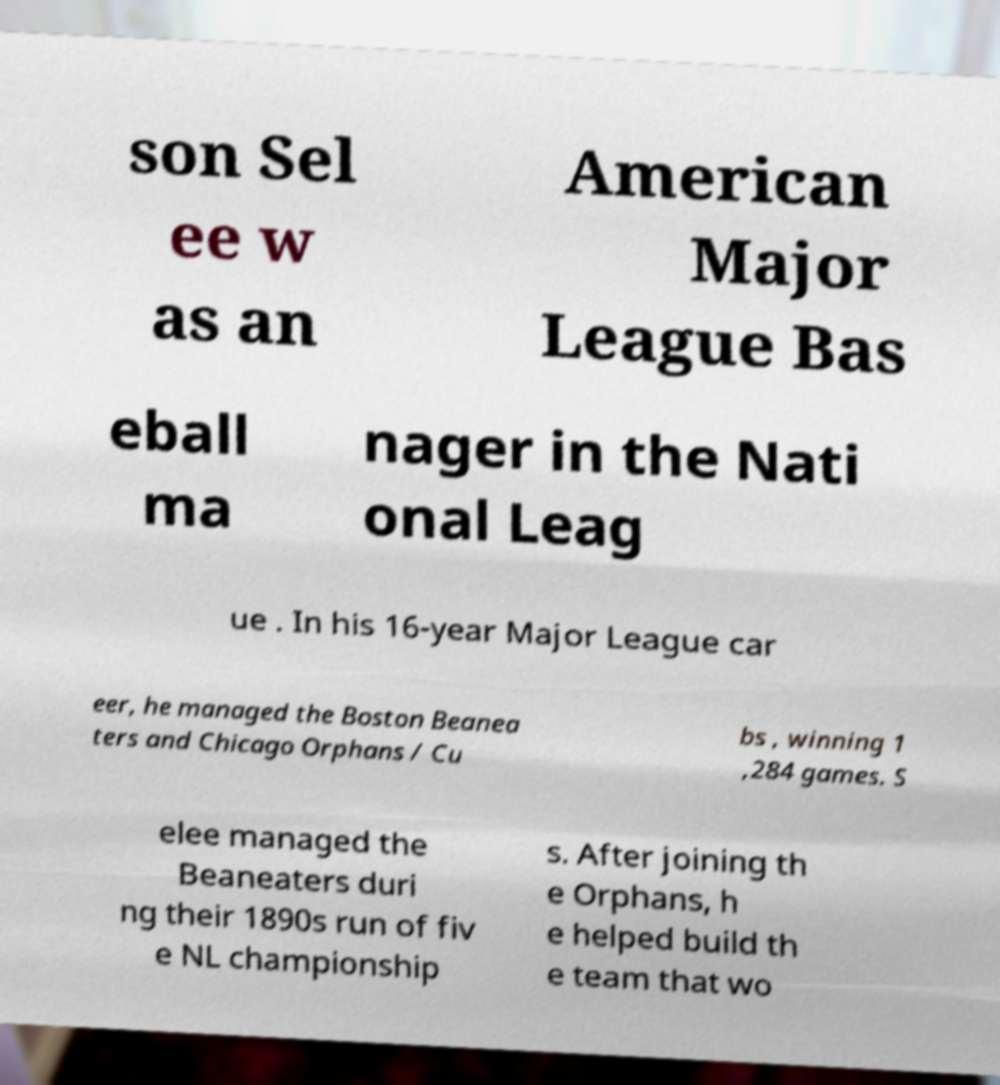Please identify and transcribe the text found in this image. son Sel ee w as an American Major League Bas eball ma nager in the Nati onal Leag ue . In his 16-year Major League car eer, he managed the Boston Beanea ters and Chicago Orphans / Cu bs , winning 1 ,284 games. S elee managed the Beaneaters duri ng their 1890s run of fiv e NL championship s. After joining th e Orphans, h e helped build th e team that wo 